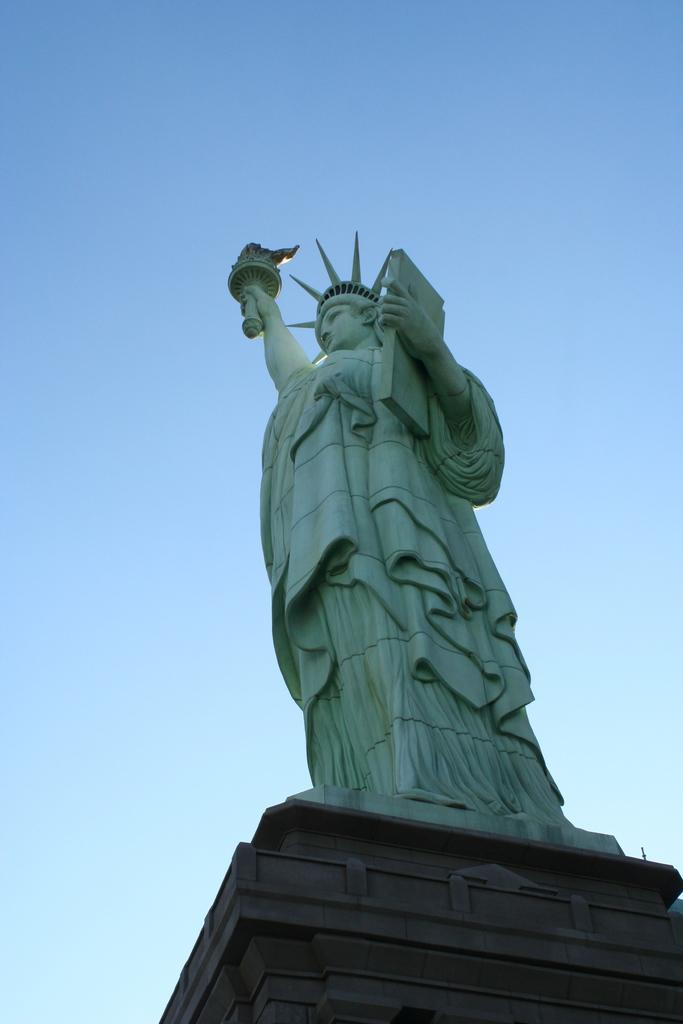What is the main subject of the image? There is a statue of liberty in the image. What is the color of the sky in the image? The sky is blue in color. Are there any cacti visible in the image? No, there are no cacti present in the image. What type of protest is taking place in the image? There is no protest depicted in the image; it features the Statue of Liberty and a blue sky. 